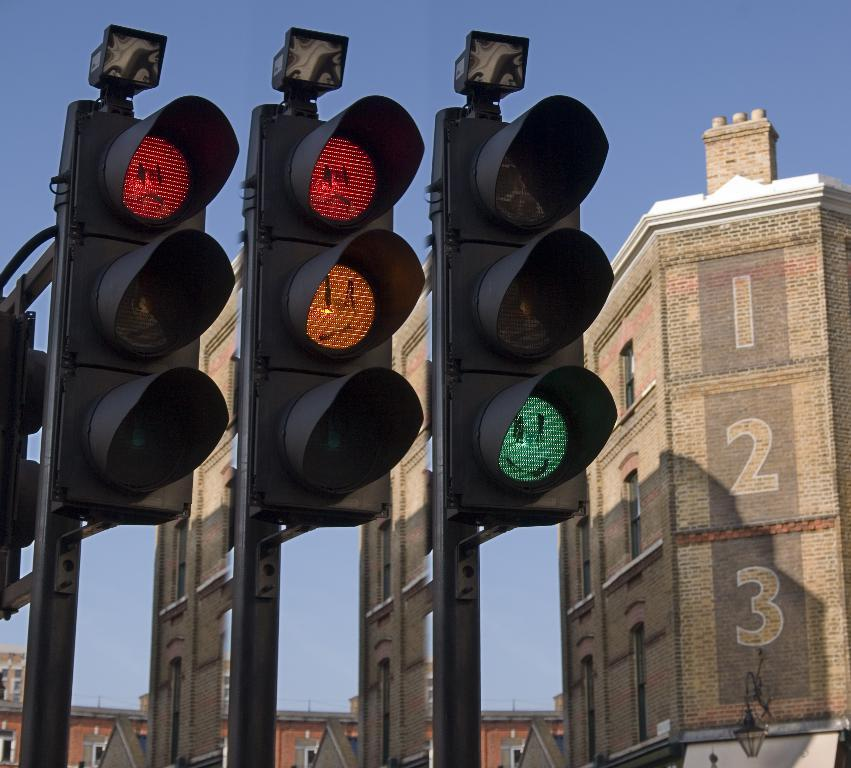Provide a one-sentence caption for the provided image. Traffic lights with smiley faces drawn over them next to a building with the numbers 1, 2 and 3 printed on them. 